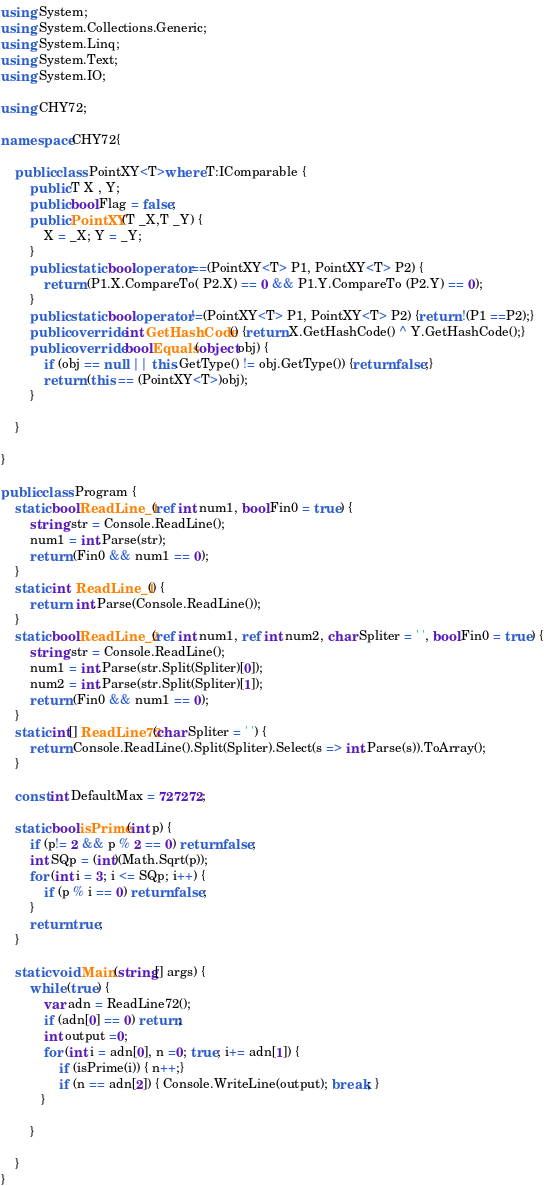<code> <loc_0><loc_0><loc_500><loc_500><_C#_>using System;
using System.Collections.Generic;
using System.Linq;
using System.Text;
using System.IO;

using CHY72;

namespace CHY72{
    
    public class PointXY<T>where T:IComparable {
        public T X , Y;
        public bool Flag = false;
        public PointXY(T _X,T _Y) {
            X = _X; Y = _Y;
        }
        public static bool operator ==(PointXY<T> P1, PointXY<T> P2) {
            return (P1.X.CompareTo( P2.X) == 0 && P1.Y.CompareTo (P2.Y) == 0);
        }
        public static bool operator !=(PointXY<T> P1, PointXY<T> P2) {return !(P1 ==P2);}
        public override int GetHashCode() {return X.GetHashCode() ^ Y.GetHashCode();}
        public override bool Equals(object obj) {
            if (obj == null || this.GetType() != obj.GetType()) {return false;}
            return (this == (PointXY<T>)obj);
        }         

    }
    
}    

public class Program {
    static bool ReadLine_1(ref int num1, bool Fin0 = true) {
        string str = Console.ReadLine();
        num1 = int.Parse(str);
        return (Fin0 && num1 == 0);
    }
    static int  ReadLine_1() {
        return  int.Parse(Console.ReadLine());
    }
    static bool ReadLine_2(ref int num1, ref int num2, char Spliter = ' ', bool Fin0 = true) {
        string str = Console.ReadLine();
        num1 = int.Parse(str.Split(Spliter)[0]);
        num2 = int.Parse(str.Split(Spliter)[1]);
        return (Fin0 && num1 == 0);
    }
    static int[] ReadLine72(char Spliter = ' ') {
        return Console.ReadLine().Split(Spliter).Select(s => int.Parse(s)).ToArray();
    }

    const int DefaultMax = 727272;

    static bool isPrime(int p) {
        if (p!= 2 && p % 2 == 0) return false;
        int SQp = (int)(Math.Sqrt(p));
        for (int i = 3; i <= SQp; i++) {
            if (p % i == 0) return false;
        }
        return true;
    } 

    static void Main(string[] args) {
        while (true) {
            var adn = ReadLine72();
            if (adn[0] == 0) return;
            int output =0;
            for (int i = adn[0], n =0; true; i+= adn[1]) {
                if (isPrime(i)) { n++;}
                if (n == adn[2]) { Console.WriteLine(output); break; }
           }
            
        }

    }
}</code> 